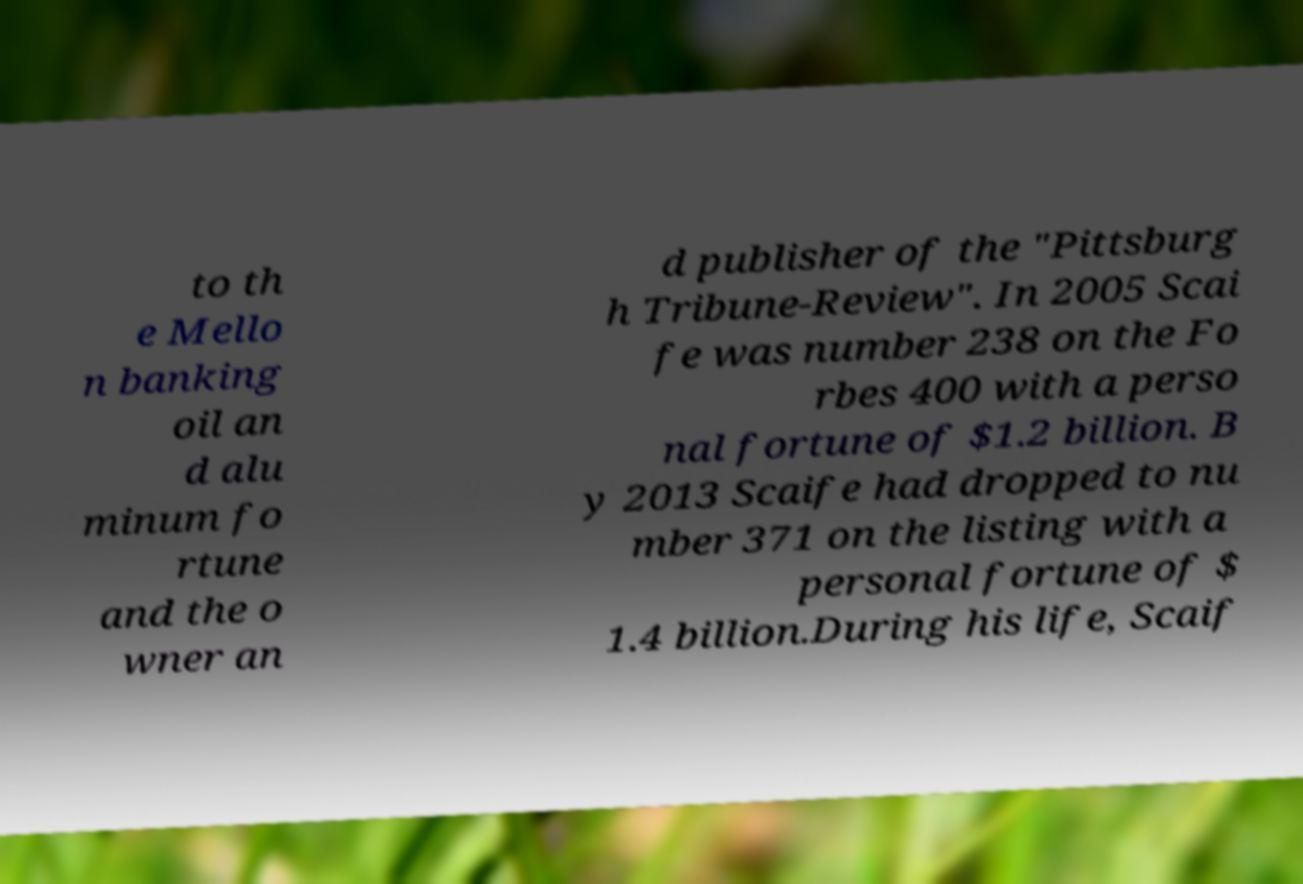I need the written content from this picture converted into text. Can you do that? to th e Mello n banking oil an d alu minum fo rtune and the o wner an d publisher of the "Pittsburg h Tribune-Review". In 2005 Scai fe was number 238 on the Fo rbes 400 with a perso nal fortune of $1.2 billion. B y 2013 Scaife had dropped to nu mber 371 on the listing with a personal fortune of $ 1.4 billion.During his life, Scaif 